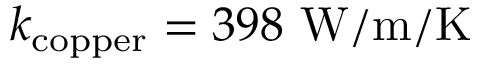<formula> <loc_0><loc_0><loc_500><loc_500>k _ { c o p p e r } = 3 9 8 \ W / m / K</formula> 